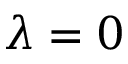Convert formula to latex. <formula><loc_0><loc_0><loc_500><loc_500>\lambda = 0</formula> 